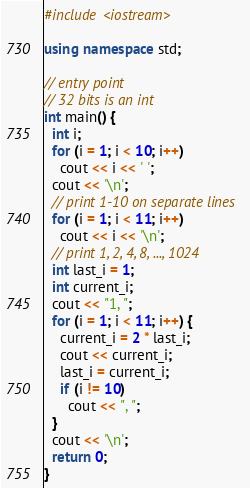Convert code to text. <code><loc_0><loc_0><loc_500><loc_500><_C++_>#include <iostream>

using namespace std;

// entry point
// 32 bits is an int
int main() {
  int i;
  for (i = 1; i < 10; i++)
    cout << i << ' ';
  cout << '\n';
  // print 1-10 on separate lines
  for (i = 1; i < 11; i++)
    cout << i << '\n';
  // print 1, 2, 4, 8, ..., 1024
  int last_i = 1;
  int current_i;
  cout << "1, ";
  for (i = 1; i < 11; i++) {
    current_i = 2 * last_i;
    cout << current_i;
    last_i = current_i;
    if (i != 10)
      cout << ", ";
  }
  cout << '\n';
  return 0;
}
</code> 